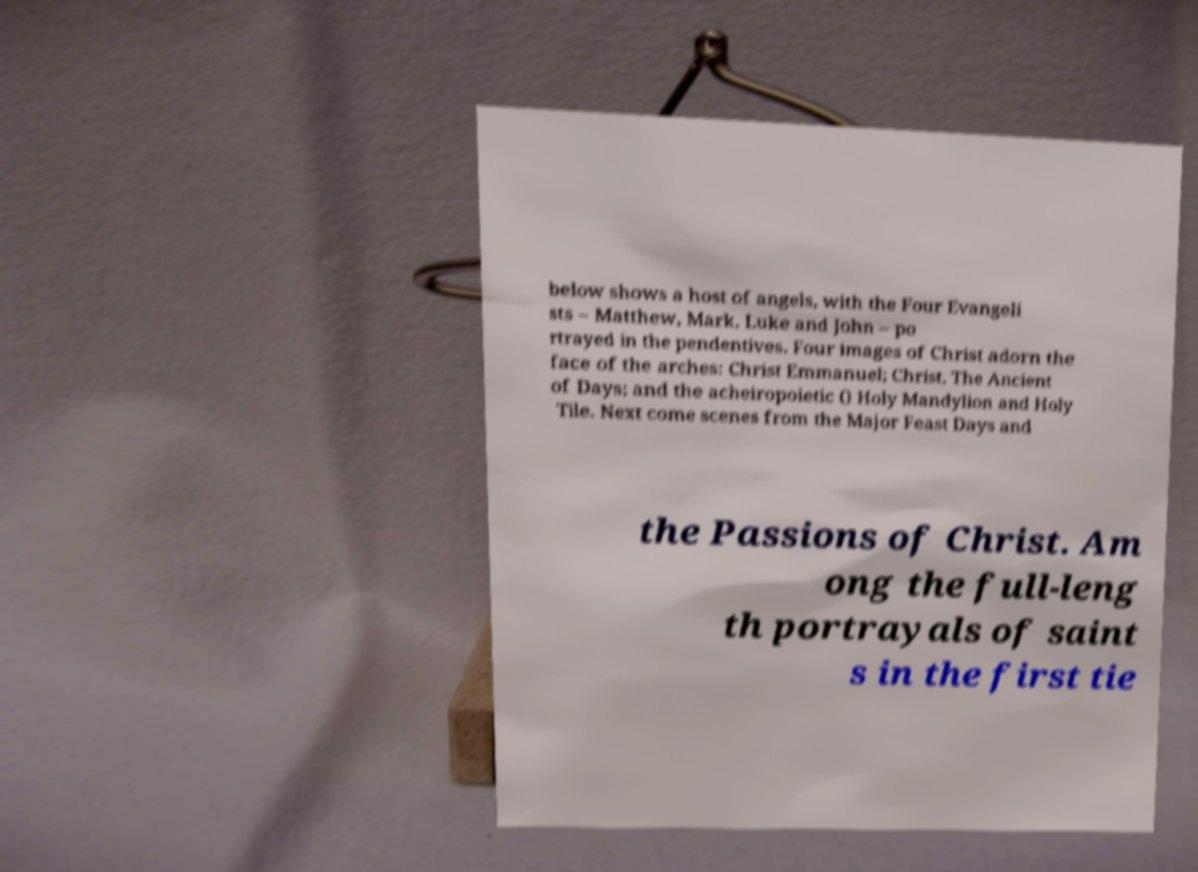Can you accurately transcribe the text from the provided image for me? below shows a host of angels, with the Four Evangeli sts – Matthew, Mark, Luke and John – po rtrayed in the pendentives. Four images of Christ adorn the face of the arches: Christ Emmanuel; Christ, The Ancient of Days; and the acheiropoietic () Holy Mandylion and Holy Tile. Next come scenes from the Major Feast Days and the Passions of Christ. Am ong the full-leng th portrayals of saint s in the first tie 